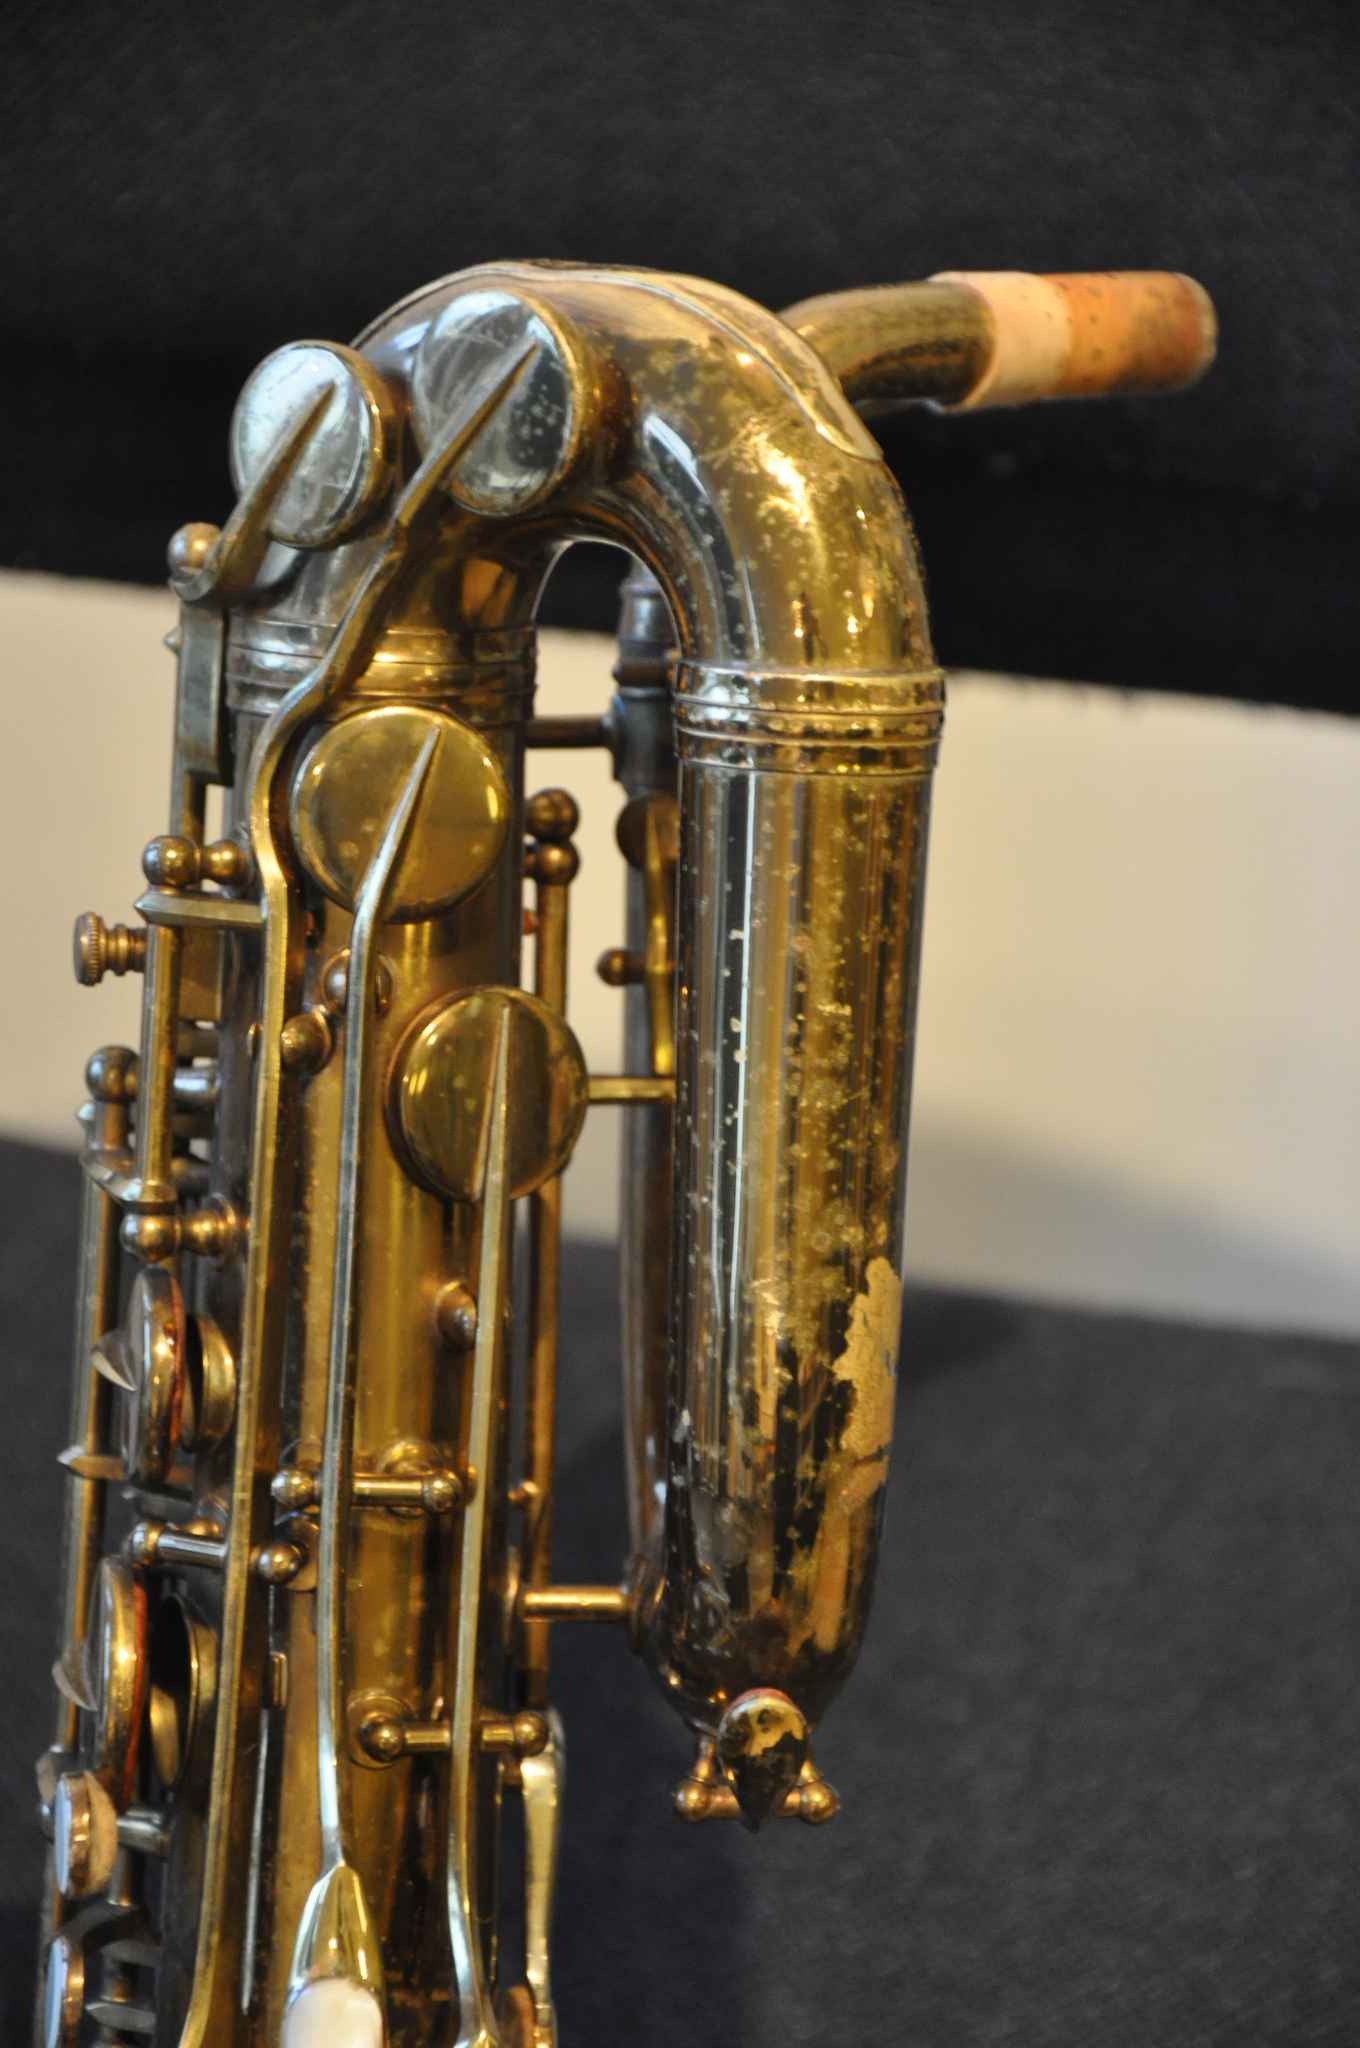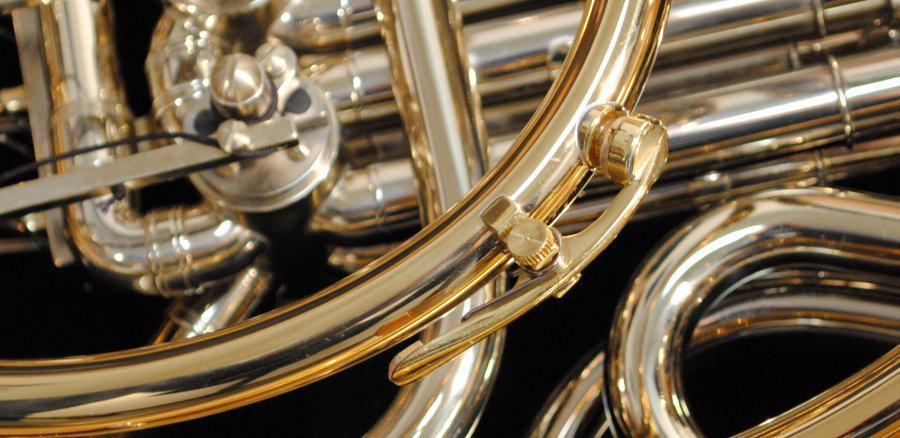The first image is the image on the left, the second image is the image on the right. Examine the images to the left and right. Is the description "The left image contains a human touching a saxophone." accurate? Answer yes or no. No. The first image is the image on the left, the second image is the image on the right. Evaluate the accuracy of this statement regarding the images: "Atleast one picture of a saxophone and no person visible.". Is it true? Answer yes or no. Yes. 